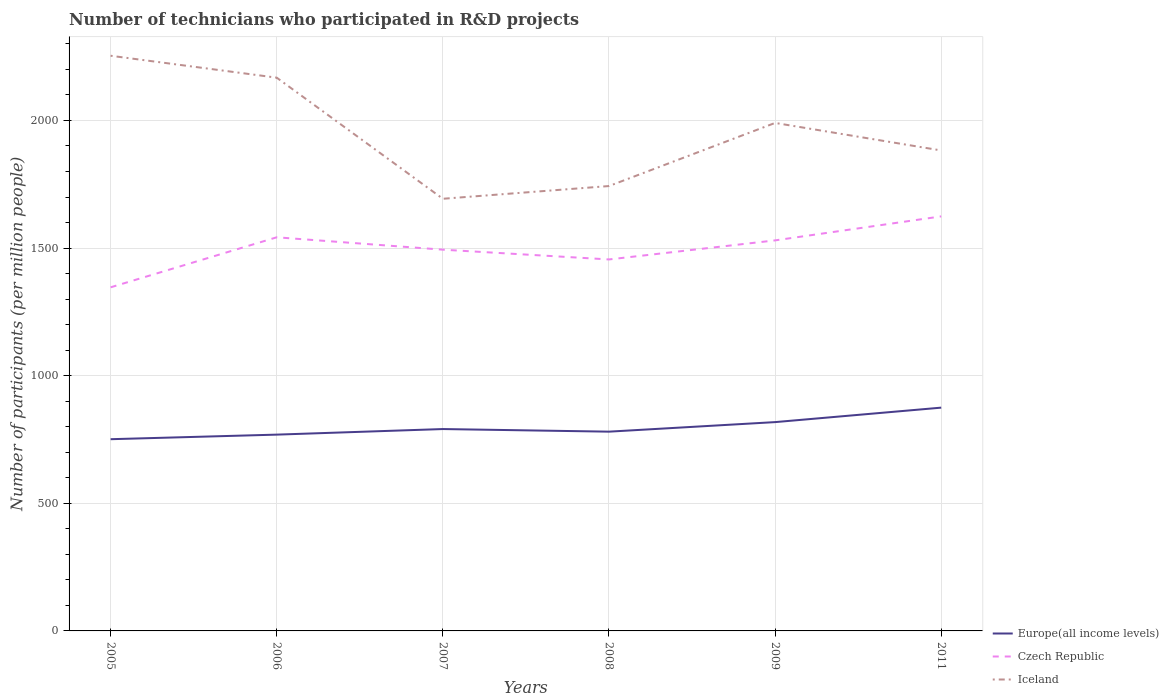How many different coloured lines are there?
Your answer should be very brief. 3. Across all years, what is the maximum number of technicians who participated in R&D projects in Czech Republic?
Provide a short and direct response. 1346.19. In which year was the number of technicians who participated in R&D projects in Europe(all income levels) maximum?
Your answer should be very brief. 2005. What is the total number of technicians who participated in R&D projects in Czech Republic in the graph?
Ensure brevity in your answer.  -183.91. What is the difference between the highest and the second highest number of technicians who participated in R&D projects in Europe(all income levels)?
Give a very brief answer. 123.66. What is the difference between the highest and the lowest number of technicians who participated in R&D projects in Iceland?
Provide a succinct answer. 3. How many lines are there?
Your answer should be very brief. 3. Does the graph contain grids?
Make the answer very short. Yes. Where does the legend appear in the graph?
Ensure brevity in your answer.  Bottom right. How are the legend labels stacked?
Offer a terse response. Vertical. What is the title of the graph?
Make the answer very short. Number of technicians who participated in R&D projects. Does "Qatar" appear as one of the legend labels in the graph?
Offer a terse response. No. What is the label or title of the Y-axis?
Offer a very short reply. Number of participants (per million people). What is the Number of participants (per million people) in Europe(all income levels) in 2005?
Provide a short and direct response. 751.1. What is the Number of participants (per million people) in Czech Republic in 2005?
Your answer should be very brief. 1346.19. What is the Number of participants (per million people) of Iceland in 2005?
Offer a very short reply. 2253.45. What is the Number of participants (per million people) of Europe(all income levels) in 2006?
Make the answer very short. 769.04. What is the Number of participants (per million people) in Czech Republic in 2006?
Provide a short and direct response. 1542.15. What is the Number of participants (per million people) of Iceland in 2006?
Keep it short and to the point. 2167.56. What is the Number of participants (per million people) in Europe(all income levels) in 2007?
Offer a very short reply. 790.9. What is the Number of participants (per million people) of Czech Republic in 2007?
Ensure brevity in your answer.  1493.68. What is the Number of participants (per million people) in Iceland in 2007?
Your answer should be compact. 1693.11. What is the Number of participants (per million people) of Europe(all income levels) in 2008?
Give a very brief answer. 780.67. What is the Number of participants (per million people) of Czech Republic in 2008?
Ensure brevity in your answer.  1455.38. What is the Number of participants (per million people) of Iceland in 2008?
Provide a short and direct response. 1742.94. What is the Number of participants (per million people) of Europe(all income levels) in 2009?
Offer a terse response. 818.09. What is the Number of participants (per million people) of Czech Republic in 2009?
Your answer should be compact. 1530.09. What is the Number of participants (per million people) of Iceland in 2009?
Your answer should be very brief. 1990.23. What is the Number of participants (per million people) of Europe(all income levels) in 2011?
Make the answer very short. 874.77. What is the Number of participants (per million people) of Czech Republic in 2011?
Offer a very short reply. 1624.14. What is the Number of participants (per million people) in Iceland in 2011?
Provide a short and direct response. 1882.38. Across all years, what is the maximum Number of participants (per million people) in Europe(all income levels)?
Ensure brevity in your answer.  874.77. Across all years, what is the maximum Number of participants (per million people) of Czech Republic?
Your response must be concise. 1624.14. Across all years, what is the maximum Number of participants (per million people) of Iceland?
Ensure brevity in your answer.  2253.45. Across all years, what is the minimum Number of participants (per million people) in Europe(all income levels)?
Offer a terse response. 751.1. Across all years, what is the minimum Number of participants (per million people) of Czech Republic?
Make the answer very short. 1346.19. Across all years, what is the minimum Number of participants (per million people) in Iceland?
Your answer should be compact. 1693.11. What is the total Number of participants (per million people) of Europe(all income levels) in the graph?
Provide a succinct answer. 4784.58. What is the total Number of participants (per million people) of Czech Republic in the graph?
Offer a very short reply. 8991.63. What is the total Number of participants (per million people) of Iceland in the graph?
Your answer should be very brief. 1.17e+04. What is the difference between the Number of participants (per million people) of Europe(all income levels) in 2005 and that in 2006?
Your answer should be compact. -17.93. What is the difference between the Number of participants (per million people) of Czech Republic in 2005 and that in 2006?
Your answer should be compact. -195.97. What is the difference between the Number of participants (per million people) in Iceland in 2005 and that in 2006?
Provide a succinct answer. 85.89. What is the difference between the Number of participants (per million people) of Europe(all income levels) in 2005 and that in 2007?
Ensure brevity in your answer.  -39.8. What is the difference between the Number of participants (per million people) of Czech Republic in 2005 and that in 2007?
Your response must be concise. -147.5. What is the difference between the Number of participants (per million people) in Iceland in 2005 and that in 2007?
Offer a terse response. 560.34. What is the difference between the Number of participants (per million people) in Europe(all income levels) in 2005 and that in 2008?
Keep it short and to the point. -29.57. What is the difference between the Number of participants (per million people) in Czech Republic in 2005 and that in 2008?
Ensure brevity in your answer.  -109.19. What is the difference between the Number of participants (per million people) of Iceland in 2005 and that in 2008?
Ensure brevity in your answer.  510.51. What is the difference between the Number of participants (per million people) in Europe(all income levels) in 2005 and that in 2009?
Your answer should be compact. -66.99. What is the difference between the Number of participants (per million people) in Czech Republic in 2005 and that in 2009?
Your response must be concise. -183.91. What is the difference between the Number of participants (per million people) of Iceland in 2005 and that in 2009?
Your answer should be very brief. 263.22. What is the difference between the Number of participants (per million people) in Europe(all income levels) in 2005 and that in 2011?
Ensure brevity in your answer.  -123.66. What is the difference between the Number of participants (per million people) of Czech Republic in 2005 and that in 2011?
Keep it short and to the point. -277.95. What is the difference between the Number of participants (per million people) in Iceland in 2005 and that in 2011?
Your answer should be very brief. 371.07. What is the difference between the Number of participants (per million people) in Europe(all income levels) in 2006 and that in 2007?
Make the answer very short. -21.86. What is the difference between the Number of participants (per million people) in Czech Republic in 2006 and that in 2007?
Your answer should be very brief. 48.47. What is the difference between the Number of participants (per million people) in Iceland in 2006 and that in 2007?
Offer a terse response. 474.45. What is the difference between the Number of participants (per million people) of Europe(all income levels) in 2006 and that in 2008?
Offer a very short reply. -11.63. What is the difference between the Number of participants (per million people) of Czech Republic in 2006 and that in 2008?
Give a very brief answer. 86.78. What is the difference between the Number of participants (per million people) in Iceland in 2006 and that in 2008?
Provide a short and direct response. 424.61. What is the difference between the Number of participants (per million people) in Europe(all income levels) in 2006 and that in 2009?
Your answer should be compact. -49.05. What is the difference between the Number of participants (per million people) in Czech Republic in 2006 and that in 2009?
Offer a terse response. 12.06. What is the difference between the Number of participants (per million people) of Iceland in 2006 and that in 2009?
Your answer should be very brief. 177.33. What is the difference between the Number of participants (per million people) in Europe(all income levels) in 2006 and that in 2011?
Keep it short and to the point. -105.73. What is the difference between the Number of participants (per million people) of Czech Republic in 2006 and that in 2011?
Give a very brief answer. -81.98. What is the difference between the Number of participants (per million people) of Iceland in 2006 and that in 2011?
Your answer should be compact. 285.18. What is the difference between the Number of participants (per million people) in Europe(all income levels) in 2007 and that in 2008?
Give a very brief answer. 10.23. What is the difference between the Number of participants (per million people) of Czech Republic in 2007 and that in 2008?
Give a very brief answer. 38.3. What is the difference between the Number of participants (per million people) in Iceland in 2007 and that in 2008?
Ensure brevity in your answer.  -49.84. What is the difference between the Number of participants (per million people) of Europe(all income levels) in 2007 and that in 2009?
Offer a terse response. -27.19. What is the difference between the Number of participants (per million people) of Czech Republic in 2007 and that in 2009?
Keep it short and to the point. -36.41. What is the difference between the Number of participants (per million people) of Iceland in 2007 and that in 2009?
Provide a short and direct response. -297.12. What is the difference between the Number of participants (per million people) of Europe(all income levels) in 2007 and that in 2011?
Keep it short and to the point. -83.87. What is the difference between the Number of participants (per million people) in Czech Republic in 2007 and that in 2011?
Give a very brief answer. -130.45. What is the difference between the Number of participants (per million people) in Iceland in 2007 and that in 2011?
Offer a terse response. -189.27. What is the difference between the Number of participants (per million people) of Europe(all income levels) in 2008 and that in 2009?
Your response must be concise. -37.42. What is the difference between the Number of participants (per million people) of Czech Republic in 2008 and that in 2009?
Your answer should be compact. -74.72. What is the difference between the Number of participants (per million people) of Iceland in 2008 and that in 2009?
Your answer should be compact. -247.28. What is the difference between the Number of participants (per million people) in Europe(all income levels) in 2008 and that in 2011?
Offer a terse response. -94.09. What is the difference between the Number of participants (per million people) in Czech Republic in 2008 and that in 2011?
Your answer should be compact. -168.76. What is the difference between the Number of participants (per million people) in Iceland in 2008 and that in 2011?
Ensure brevity in your answer.  -139.44. What is the difference between the Number of participants (per million people) of Europe(all income levels) in 2009 and that in 2011?
Ensure brevity in your answer.  -56.67. What is the difference between the Number of participants (per million people) of Czech Republic in 2009 and that in 2011?
Provide a succinct answer. -94.04. What is the difference between the Number of participants (per million people) of Iceland in 2009 and that in 2011?
Your response must be concise. 107.85. What is the difference between the Number of participants (per million people) of Europe(all income levels) in 2005 and the Number of participants (per million people) of Czech Republic in 2006?
Ensure brevity in your answer.  -791.05. What is the difference between the Number of participants (per million people) in Europe(all income levels) in 2005 and the Number of participants (per million people) in Iceland in 2006?
Your answer should be compact. -1416.45. What is the difference between the Number of participants (per million people) of Czech Republic in 2005 and the Number of participants (per million people) of Iceland in 2006?
Offer a terse response. -821.37. What is the difference between the Number of participants (per million people) in Europe(all income levels) in 2005 and the Number of participants (per million people) in Czech Republic in 2007?
Your answer should be very brief. -742.58. What is the difference between the Number of participants (per million people) of Europe(all income levels) in 2005 and the Number of participants (per million people) of Iceland in 2007?
Keep it short and to the point. -942. What is the difference between the Number of participants (per million people) in Czech Republic in 2005 and the Number of participants (per million people) in Iceland in 2007?
Ensure brevity in your answer.  -346.92. What is the difference between the Number of participants (per million people) of Europe(all income levels) in 2005 and the Number of participants (per million people) of Czech Republic in 2008?
Your answer should be compact. -704.27. What is the difference between the Number of participants (per million people) of Europe(all income levels) in 2005 and the Number of participants (per million people) of Iceland in 2008?
Provide a succinct answer. -991.84. What is the difference between the Number of participants (per million people) of Czech Republic in 2005 and the Number of participants (per million people) of Iceland in 2008?
Provide a short and direct response. -396.76. What is the difference between the Number of participants (per million people) of Europe(all income levels) in 2005 and the Number of participants (per million people) of Czech Republic in 2009?
Give a very brief answer. -778.99. What is the difference between the Number of participants (per million people) of Europe(all income levels) in 2005 and the Number of participants (per million people) of Iceland in 2009?
Keep it short and to the point. -1239.12. What is the difference between the Number of participants (per million people) in Czech Republic in 2005 and the Number of participants (per million people) in Iceland in 2009?
Your answer should be compact. -644.04. What is the difference between the Number of participants (per million people) in Europe(all income levels) in 2005 and the Number of participants (per million people) in Czech Republic in 2011?
Your answer should be compact. -873.03. What is the difference between the Number of participants (per million people) in Europe(all income levels) in 2005 and the Number of participants (per million people) in Iceland in 2011?
Offer a very short reply. -1131.28. What is the difference between the Number of participants (per million people) in Czech Republic in 2005 and the Number of participants (per million people) in Iceland in 2011?
Give a very brief answer. -536.19. What is the difference between the Number of participants (per million people) in Europe(all income levels) in 2006 and the Number of participants (per million people) in Czech Republic in 2007?
Keep it short and to the point. -724.64. What is the difference between the Number of participants (per million people) of Europe(all income levels) in 2006 and the Number of participants (per million people) of Iceland in 2007?
Provide a succinct answer. -924.07. What is the difference between the Number of participants (per million people) of Czech Republic in 2006 and the Number of participants (per million people) of Iceland in 2007?
Give a very brief answer. -150.95. What is the difference between the Number of participants (per million people) of Europe(all income levels) in 2006 and the Number of participants (per million people) of Czech Republic in 2008?
Your response must be concise. -686.34. What is the difference between the Number of participants (per million people) of Europe(all income levels) in 2006 and the Number of participants (per million people) of Iceland in 2008?
Ensure brevity in your answer.  -973.91. What is the difference between the Number of participants (per million people) of Czech Republic in 2006 and the Number of participants (per million people) of Iceland in 2008?
Ensure brevity in your answer.  -200.79. What is the difference between the Number of participants (per million people) in Europe(all income levels) in 2006 and the Number of participants (per million people) in Czech Republic in 2009?
Make the answer very short. -761.06. What is the difference between the Number of participants (per million people) of Europe(all income levels) in 2006 and the Number of participants (per million people) of Iceland in 2009?
Your answer should be compact. -1221.19. What is the difference between the Number of participants (per million people) in Czech Republic in 2006 and the Number of participants (per million people) in Iceland in 2009?
Make the answer very short. -448.07. What is the difference between the Number of participants (per million people) of Europe(all income levels) in 2006 and the Number of participants (per million people) of Czech Republic in 2011?
Your answer should be very brief. -855.1. What is the difference between the Number of participants (per million people) in Europe(all income levels) in 2006 and the Number of participants (per million people) in Iceland in 2011?
Provide a succinct answer. -1113.34. What is the difference between the Number of participants (per million people) of Czech Republic in 2006 and the Number of participants (per million people) of Iceland in 2011?
Provide a short and direct response. -340.22. What is the difference between the Number of participants (per million people) of Europe(all income levels) in 2007 and the Number of participants (per million people) of Czech Republic in 2008?
Your answer should be very brief. -664.47. What is the difference between the Number of participants (per million people) of Europe(all income levels) in 2007 and the Number of participants (per million people) of Iceland in 2008?
Offer a terse response. -952.04. What is the difference between the Number of participants (per million people) in Czech Republic in 2007 and the Number of participants (per million people) in Iceland in 2008?
Your answer should be compact. -249.26. What is the difference between the Number of participants (per million people) of Europe(all income levels) in 2007 and the Number of participants (per million people) of Czech Republic in 2009?
Offer a very short reply. -739.19. What is the difference between the Number of participants (per million people) in Europe(all income levels) in 2007 and the Number of participants (per million people) in Iceland in 2009?
Give a very brief answer. -1199.32. What is the difference between the Number of participants (per million people) in Czech Republic in 2007 and the Number of participants (per million people) in Iceland in 2009?
Make the answer very short. -496.55. What is the difference between the Number of participants (per million people) in Europe(all income levels) in 2007 and the Number of participants (per million people) in Czech Republic in 2011?
Offer a terse response. -833.23. What is the difference between the Number of participants (per million people) of Europe(all income levels) in 2007 and the Number of participants (per million people) of Iceland in 2011?
Your answer should be very brief. -1091.48. What is the difference between the Number of participants (per million people) of Czech Republic in 2007 and the Number of participants (per million people) of Iceland in 2011?
Offer a terse response. -388.7. What is the difference between the Number of participants (per million people) of Europe(all income levels) in 2008 and the Number of participants (per million people) of Czech Republic in 2009?
Your answer should be compact. -749.42. What is the difference between the Number of participants (per million people) in Europe(all income levels) in 2008 and the Number of participants (per million people) in Iceland in 2009?
Your answer should be very brief. -1209.55. What is the difference between the Number of participants (per million people) in Czech Republic in 2008 and the Number of participants (per million people) in Iceland in 2009?
Your answer should be very brief. -534.85. What is the difference between the Number of participants (per million people) of Europe(all income levels) in 2008 and the Number of participants (per million people) of Czech Republic in 2011?
Offer a very short reply. -843.46. What is the difference between the Number of participants (per million people) of Europe(all income levels) in 2008 and the Number of participants (per million people) of Iceland in 2011?
Your answer should be compact. -1101.71. What is the difference between the Number of participants (per million people) in Czech Republic in 2008 and the Number of participants (per million people) in Iceland in 2011?
Provide a short and direct response. -427. What is the difference between the Number of participants (per million people) of Europe(all income levels) in 2009 and the Number of participants (per million people) of Czech Republic in 2011?
Make the answer very short. -806.04. What is the difference between the Number of participants (per million people) of Europe(all income levels) in 2009 and the Number of participants (per million people) of Iceland in 2011?
Give a very brief answer. -1064.29. What is the difference between the Number of participants (per million people) of Czech Republic in 2009 and the Number of participants (per million people) of Iceland in 2011?
Provide a short and direct response. -352.28. What is the average Number of participants (per million people) of Europe(all income levels) per year?
Keep it short and to the point. 797.43. What is the average Number of participants (per million people) of Czech Republic per year?
Make the answer very short. 1498.6. What is the average Number of participants (per million people) of Iceland per year?
Your response must be concise. 1954.94. In the year 2005, what is the difference between the Number of participants (per million people) of Europe(all income levels) and Number of participants (per million people) of Czech Republic?
Your answer should be very brief. -595.08. In the year 2005, what is the difference between the Number of participants (per million people) in Europe(all income levels) and Number of participants (per million people) in Iceland?
Offer a very short reply. -1502.35. In the year 2005, what is the difference between the Number of participants (per million people) in Czech Republic and Number of participants (per million people) in Iceland?
Your answer should be very brief. -907.26. In the year 2006, what is the difference between the Number of participants (per million people) of Europe(all income levels) and Number of participants (per million people) of Czech Republic?
Offer a very short reply. -773.12. In the year 2006, what is the difference between the Number of participants (per million people) of Europe(all income levels) and Number of participants (per million people) of Iceland?
Make the answer very short. -1398.52. In the year 2006, what is the difference between the Number of participants (per million people) in Czech Republic and Number of participants (per million people) in Iceland?
Provide a succinct answer. -625.4. In the year 2007, what is the difference between the Number of participants (per million people) in Europe(all income levels) and Number of participants (per million people) in Czech Republic?
Your response must be concise. -702.78. In the year 2007, what is the difference between the Number of participants (per million people) of Europe(all income levels) and Number of participants (per million people) of Iceland?
Give a very brief answer. -902.2. In the year 2007, what is the difference between the Number of participants (per million people) in Czech Republic and Number of participants (per million people) in Iceland?
Provide a short and direct response. -199.42. In the year 2008, what is the difference between the Number of participants (per million people) in Europe(all income levels) and Number of participants (per million people) in Czech Republic?
Make the answer very short. -674.7. In the year 2008, what is the difference between the Number of participants (per million people) in Europe(all income levels) and Number of participants (per million people) in Iceland?
Make the answer very short. -962.27. In the year 2008, what is the difference between the Number of participants (per million people) of Czech Republic and Number of participants (per million people) of Iceland?
Your response must be concise. -287.57. In the year 2009, what is the difference between the Number of participants (per million people) in Europe(all income levels) and Number of participants (per million people) in Czech Republic?
Your answer should be compact. -712. In the year 2009, what is the difference between the Number of participants (per million people) in Europe(all income levels) and Number of participants (per million people) in Iceland?
Make the answer very short. -1172.13. In the year 2009, what is the difference between the Number of participants (per million people) in Czech Republic and Number of participants (per million people) in Iceland?
Ensure brevity in your answer.  -460.13. In the year 2011, what is the difference between the Number of participants (per million people) of Europe(all income levels) and Number of participants (per million people) of Czech Republic?
Offer a terse response. -749.37. In the year 2011, what is the difference between the Number of participants (per million people) in Europe(all income levels) and Number of participants (per million people) in Iceland?
Offer a terse response. -1007.61. In the year 2011, what is the difference between the Number of participants (per million people) in Czech Republic and Number of participants (per million people) in Iceland?
Provide a succinct answer. -258.24. What is the ratio of the Number of participants (per million people) of Europe(all income levels) in 2005 to that in 2006?
Give a very brief answer. 0.98. What is the ratio of the Number of participants (per million people) of Czech Republic in 2005 to that in 2006?
Offer a terse response. 0.87. What is the ratio of the Number of participants (per million people) of Iceland in 2005 to that in 2006?
Keep it short and to the point. 1.04. What is the ratio of the Number of participants (per million people) of Europe(all income levels) in 2005 to that in 2007?
Keep it short and to the point. 0.95. What is the ratio of the Number of participants (per million people) in Czech Republic in 2005 to that in 2007?
Keep it short and to the point. 0.9. What is the ratio of the Number of participants (per million people) of Iceland in 2005 to that in 2007?
Offer a terse response. 1.33. What is the ratio of the Number of participants (per million people) of Europe(all income levels) in 2005 to that in 2008?
Make the answer very short. 0.96. What is the ratio of the Number of participants (per million people) of Czech Republic in 2005 to that in 2008?
Offer a terse response. 0.93. What is the ratio of the Number of participants (per million people) in Iceland in 2005 to that in 2008?
Ensure brevity in your answer.  1.29. What is the ratio of the Number of participants (per million people) in Europe(all income levels) in 2005 to that in 2009?
Provide a short and direct response. 0.92. What is the ratio of the Number of participants (per million people) of Czech Republic in 2005 to that in 2009?
Your answer should be compact. 0.88. What is the ratio of the Number of participants (per million people) in Iceland in 2005 to that in 2009?
Your response must be concise. 1.13. What is the ratio of the Number of participants (per million people) of Europe(all income levels) in 2005 to that in 2011?
Make the answer very short. 0.86. What is the ratio of the Number of participants (per million people) in Czech Republic in 2005 to that in 2011?
Make the answer very short. 0.83. What is the ratio of the Number of participants (per million people) in Iceland in 2005 to that in 2011?
Give a very brief answer. 1.2. What is the ratio of the Number of participants (per million people) of Europe(all income levels) in 2006 to that in 2007?
Provide a short and direct response. 0.97. What is the ratio of the Number of participants (per million people) of Czech Republic in 2006 to that in 2007?
Offer a very short reply. 1.03. What is the ratio of the Number of participants (per million people) in Iceland in 2006 to that in 2007?
Your response must be concise. 1.28. What is the ratio of the Number of participants (per million people) in Europe(all income levels) in 2006 to that in 2008?
Provide a succinct answer. 0.99. What is the ratio of the Number of participants (per million people) in Czech Republic in 2006 to that in 2008?
Your answer should be compact. 1.06. What is the ratio of the Number of participants (per million people) of Iceland in 2006 to that in 2008?
Provide a succinct answer. 1.24. What is the ratio of the Number of participants (per million people) in Europe(all income levels) in 2006 to that in 2009?
Make the answer very short. 0.94. What is the ratio of the Number of participants (per million people) in Czech Republic in 2006 to that in 2009?
Provide a short and direct response. 1.01. What is the ratio of the Number of participants (per million people) in Iceland in 2006 to that in 2009?
Your answer should be compact. 1.09. What is the ratio of the Number of participants (per million people) in Europe(all income levels) in 2006 to that in 2011?
Provide a succinct answer. 0.88. What is the ratio of the Number of participants (per million people) in Czech Republic in 2006 to that in 2011?
Give a very brief answer. 0.95. What is the ratio of the Number of participants (per million people) of Iceland in 2006 to that in 2011?
Ensure brevity in your answer.  1.15. What is the ratio of the Number of participants (per million people) of Europe(all income levels) in 2007 to that in 2008?
Give a very brief answer. 1.01. What is the ratio of the Number of participants (per million people) in Czech Republic in 2007 to that in 2008?
Provide a succinct answer. 1.03. What is the ratio of the Number of participants (per million people) in Iceland in 2007 to that in 2008?
Offer a very short reply. 0.97. What is the ratio of the Number of participants (per million people) in Europe(all income levels) in 2007 to that in 2009?
Keep it short and to the point. 0.97. What is the ratio of the Number of participants (per million people) of Czech Republic in 2007 to that in 2009?
Provide a succinct answer. 0.98. What is the ratio of the Number of participants (per million people) in Iceland in 2007 to that in 2009?
Offer a very short reply. 0.85. What is the ratio of the Number of participants (per million people) in Europe(all income levels) in 2007 to that in 2011?
Your answer should be very brief. 0.9. What is the ratio of the Number of participants (per million people) in Czech Republic in 2007 to that in 2011?
Your answer should be very brief. 0.92. What is the ratio of the Number of participants (per million people) of Iceland in 2007 to that in 2011?
Your answer should be very brief. 0.9. What is the ratio of the Number of participants (per million people) of Europe(all income levels) in 2008 to that in 2009?
Keep it short and to the point. 0.95. What is the ratio of the Number of participants (per million people) of Czech Republic in 2008 to that in 2009?
Give a very brief answer. 0.95. What is the ratio of the Number of participants (per million people) of Iceland in 2008 to that in 2009?
Keep it short and to the point. 0.88. What is the ratio of the Number of participants (per million people) of Europe(all income levels) in 2008 to that in 2011?
Offer a very short reply. 0.89. What is the ratio of the Number of participants (per million people) in Czech Republic in 2008 to that in 2011?
Ensure brevity in your answer.  0.9. What is the ratio of the Number of participants (per million people) in Iceland in 2008 to that in 2011?
Your response must be concise. 0.93. What is the ratio of the Number of participants (per million people) of Europe(all income levels) in 2009 to that in 2011?
Give a very brief answer. 0.94. What is the ratio of the Number of participants (per million people) in Czech Republic in 2009 to that in 2011?
Ensure brevity in your answer.  0.94. What is the ratio of the Number of participants (per million people) of Iceland in 2009 to that in 2011?
Give a very brief answer. 1.06. What is the difference between the highest and the second highest Number of participants (per million people) of Europe(all income levels)?
Give a very brief answer. 56.67. What is the difference between the highest and the second highest Number of participants (per million people) in Czech Republic?
Your response must be concise. 81.98. What is the difference between the highest and the second highest Number of participants (per million people) in Iceland?
Make the answer very short. 85.89. What is the difference between the highest and the lowest Number of participants (per million people) in Europe(all income levels)?
Ensure brevity in your answer.  123.66. What is the difference between the highest and the lowest Number of participants (per million people) of Czech Republic?
Your response must be concise. 277.95. What is the difference between the highest and the lowest Number of participants (per million people) of Iceland?
Your answer should be very brief. 560.34. 